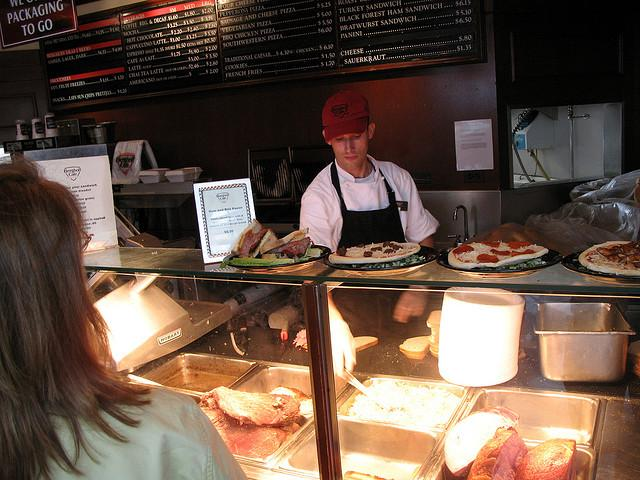What type of meat is most visible near the front of the glass? Please explain your reasoning. red meat. The meat is red meat. 